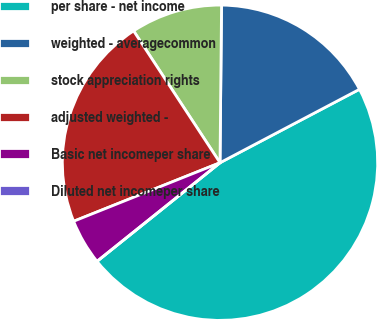Convert chart. <chart><loc_0><loc_0><loc_500><loc_500><pie_chart><fcel>per share - net income<fcel>weighted - averagecommon<fcel>stock appreciation rights<fcel>adjusted weighted -<fcel>Basic net incomeper share<fcel>Diluted net incomeper share<nl><fcel>46.96%<fcel>17.13%<fcel>9.39%<fcel>21.82%<fcel>4.7%<fcel>0.0%<nl></chart> 